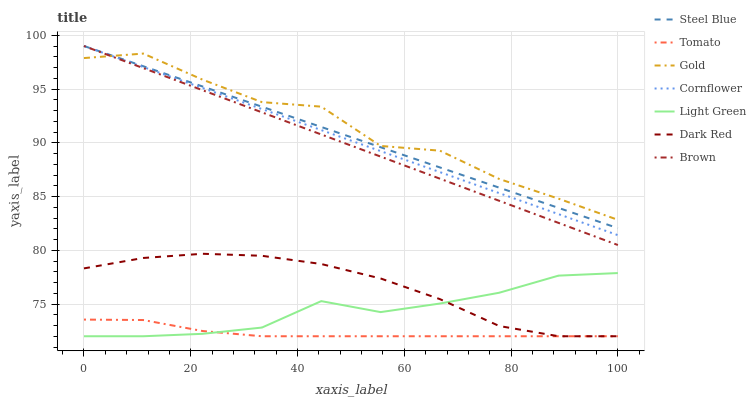Does Cornflower have the minimum area under the curve?
Answer yes or no. No. Does Cornflower have the maximum area under the curve?
Answer yes or no. No. Is Cornflower the smoothest?
Answer yes or no. No. Is Cornflower the roughest?
Answer yes or no. No. Does Cornflower have the lowest value?
Answer yes or no. No. Does Gold have the highest value?
Answer yes or no. No. Is Tomato less than Steel Blue?
Answer yes or no. Yes. Is Steel Blue greater than Dark Red?
Answer yes or no. Yes. Does Tomato intersect Steel Blue?
Answer yes or no. No. 